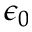<formula> <loc_0><loc_0><loc_500><loc_500>\epsilon _ { 0 }</formula> 